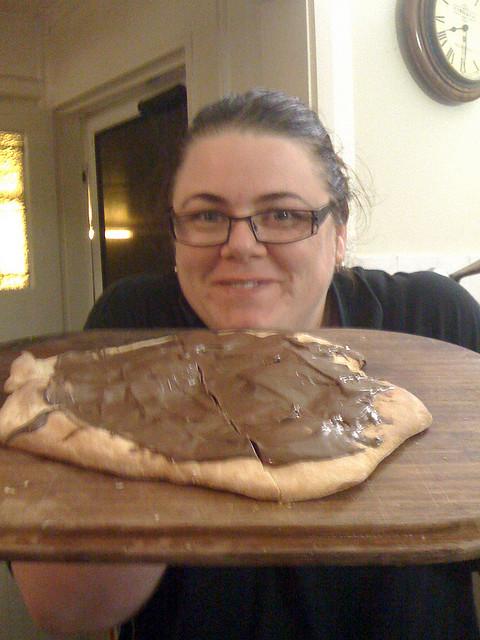Is the person wearing glasses?
Concise answer only. Yes. Is that a man or a woman?
Short answer required. Woman. Is this person happy?
Write a very short answer. Yes. 